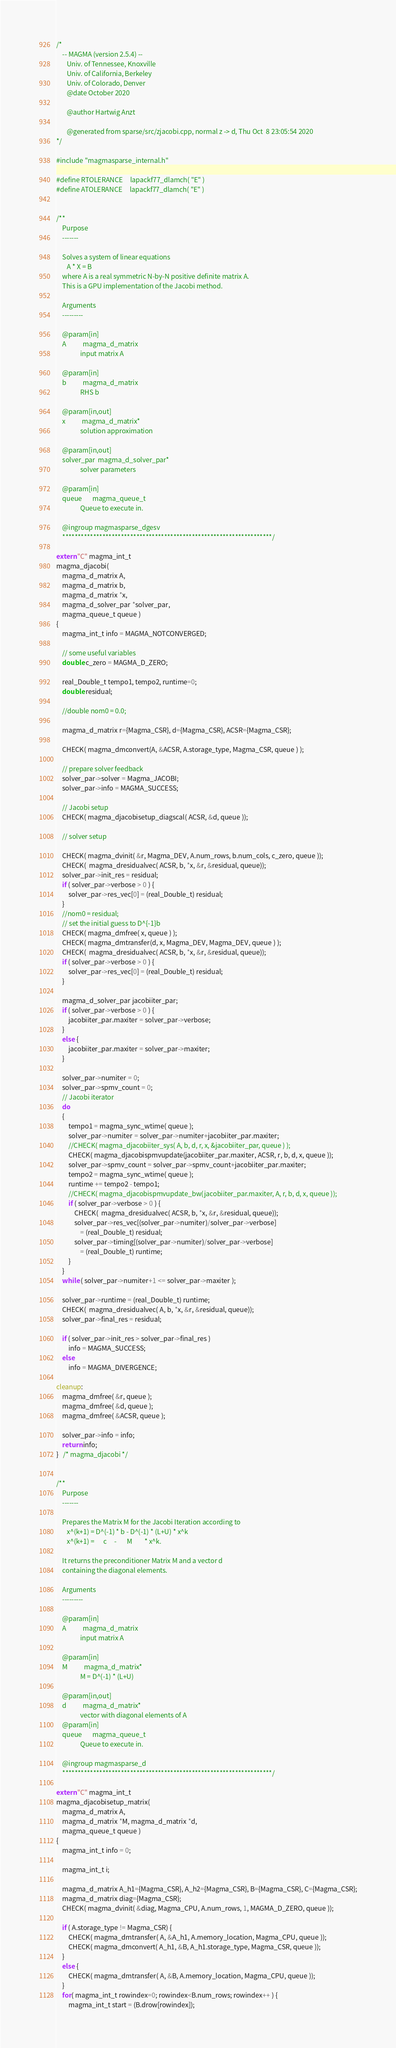Convert code to text. <code><loc_0><loc_0><loc_500><loc_500><_C++_>/*
    -- MAGMA (version 2.5.4) --
       Univ. of Tennessee, Knoxville
       Univ. of California, Berkeley
       Univ. of Colorado, Denver
       @date October 2020

       @author Hartwig Anzt

       @generated from sparse/src/zjacobi.cpp, normal z -> d, Thu Oct  8 23:05:54 2020
*/

#include "magmasparse_internal.h"

#define RTOLERANCE     lapackf77_dlamch( "E" )
#define ATOLERANCE     lapackf77_dlamch( "E" )


/**
    Purpose
    -------

    Solves a system of linear equations
       A * X = B
    where A is a real symmetric N-by-N positive definite matrix A.
    This is a GPU implementation of the Jacobi method.

    Arguments
    ---------

    @param[in]
    A           magma_d_matrix
                input matrix A

    @param[in]
    b           magma_d_matrix
                RHS b

    @param[in,out]
    x           magma_d_matrix*
                solution approximation

    @param[in,out]
    solver_par  magma_d_solver_par*
                solver parameters

    @param[in]
    queue       magma_queue_t
                Queue to execute in.

    @ingroup magmasparse_dgesv
    ********************************************************************/

extern "C" magma_int_t
magma_djacobi(
    magma_d_matrix A,
    magma_d_matrix b,
    magma_d_matrix *x,
    magma_d_solver_par *solver_par,
    magma_queue_t queue )
{
    magma_int_t info = MAGMA_NOTCONVERGED;
    
    // some useful variables
    double c_zero = MAGMA_D_ZERO;
    
    real_Double_t tempo1, tempo2, runtime=0;
    double residual;
    
    //double nom0 = 0.0;

    magma_d_matrix r={Magma_CSR}, d={Magma_CSR}, ACSR={Magma_CSR};

    CHECK( magma_dmconvert(A, &ACSR, A.storage_type, Magma_CSR, queue ) );
    
    // prepare solver feedback
    solver_par->solver = Magma_JACOBI;
    solver_par->info = MAGMA_SUCCESS;

    // Jacobi setup
    CHECK( magma_djacobisetup_diagscal( ACSR, &d, queue ));
    
    // solver setup
    
    CHECK( magma_dvinit( &r, Magma_DEV, A.num_rows, b.num_cols, c_zero, queue ));
    CHECK(  magma_dresidualvec( ACSR, b, *x, &r, &residual, queue));
    solver_par->init_res = residual;
    if ( solver_par->verbose > 0 ) {
        solver_par->res_vec[0] = (real_Double_t) residual;
    }
    //nom0 = residual;
    // set the initial guess to D^{-1}b
    CHECK( magma_dmfree( x, queue ) );
    CHECK( magma_dmtransfer(d, x, Magma_DEV, Magma_DEV, queue ) );
    CHECK(  magma_dresidualvec( ACSR, b, *x, &r, &residual, queue));
    if ( solver_par->verbose > 0 ) {
        solver_par->res_vec[0] = (real_Double_t) residual;
    }

    magma_d_solver_par jacobiiter_par;
    if ( solver_par->verbose > 0 ) {
        jacobiiter_par.maxiter = solver_par->verbose;
    }
    else {
        jacobiiter_par.maxiter = solver_par->maxiter;
    }

    solver_par->numiter = 0;
    solver_par->spmv_count = 0;
    // Jacobi iterator
    do
    {
        tempo1 = magma_sync_wtime( queue );
        solver_par->numiter = solver_par->numiter+jacobiiter_par.maxiter;
        //CHECK( magma_djacobiiter_sys( A, b, d, r, x, &jacobiiter_par, queue ) );
        CHECK( magma_djacobispmvupdate(jacobiiter_par.maxiter, ACSR, r, b, d, x, queue ));
        solver_par->spmv_count = solver_par->spmv_count+jacobiiter_par.maxiter;
        tempo2 = magma_sync_wtime( queue );
        runtime += tempo2 - tempo1;
        //CHECK( magma_djacobispmvupdate_bw(jacobiiter_par.maxiter, A, r, b, d, x, queue ));
        if ( solver_par->verbose > 0 ) {
            CHECK(  magma_dresidualvec( ACSR, b, *x, &r, &residual, queue));
            solver_par->res_vec[(solver_par->numiter)/solver_par->verbose]
                = (real_Double_t) residual;
            solver_par->timing[(solver_par->numiter)/solver_par->verbose]
                = (real_Double_t) runtime;
        }
    }
    while ( solver_par->numiter+1 <= solver_par->maxiter );

    solver_par->runtime = (real_Double_t) runtime;
    CHECK(  magma_dresidualvec( A, b, *x, &r, &residual, queue));
    solver_par->final_res = residual;

    if ( solver_par->init_res > solver_par->final_res )
        info = MAGMA_SUCCESS;
    else
        info = MAGMA_DIVERGENCE;

cleanup:
    magma_dmfree( &r, queue );
    magma_dmfree( &d, queue );
    magma_dmfree( &ACSR, queue );

    solver_par->info = info;
    return info;
}   /* magma_djacobi */


/**
    Purpose
    -------

    Prepares the Matrix M for the Jacobi Iteration according to
       x^(k+1) = D^(-1) * b - D^(-1) * (L+U) * x^k
       x^(k+1) =      c     -       M        * x^k.

    It returns the preconditioner Matrix M and a vector d
    containing the diagonal elements.

    Arguments
    ---------

    @param[in]
    A           magma_d_matrix
                input matrix A

    @param[in]
    M           magma_d_matrix*
                M = D^(-1) * (L+U)

    @param[in,out]
    d           magma_d_matrix*
                vector with diagonal elements of A
    @param[in]
    queue       magma_queue_t
                Queue to execute in.

    @ingroup magmasparse_d
    ********************************************************************/

extern "C" magma_int_t
magma_djacobisetup_matrix(
    magma_d_matrix A,
    magma_d_matrix *M, magma_d_matrix *d,
    magma_queue_t queue )
{
    magma_int_t info = 0;
    
    magma_int_t i;

    magma_d_matrix A_h1={Magma_CSR}, A_h2={Magma_CSR}, B={Magma_CSR}, C={Magma_CSR};
    magma_d_matrix diag={Magma_CSR};
    CHECK( magma_dvinit( &diag, Magma_CPU, A.num_rows, 1, MAGMA_D_ZERO, queue ));

    if ( A.storage_type != Magma_CSR) {
        CHECK( magma_dmtransfer( A, &A_h1, A.memory_location, Magma_CPU, queue ));
        CHECK( magma_dmconvert( A_h1, &B, A_h1.storage_type, Magma_CSR, queue ));
    }
    else {
        CHECK( magma_dmtransfer( A, &B, A.memory_location, Magma_CPU, queue ));
    }
    for( magma_int_t rowindex=0; rowindex<B.num_rows; rowindex++ ) {
        magma_int_t start = (B.drow[rowindex]);</code> 